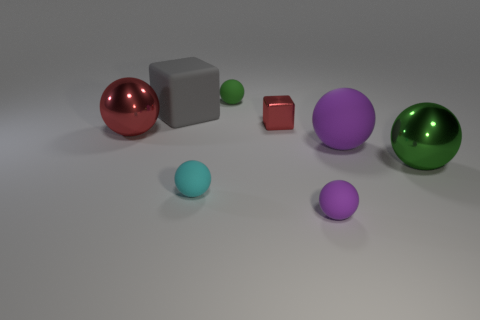What shape is the shiny thing that is left of the tiny green thing to the left of the green sphere that is in front of the small red object?
Keep it short and to the point. Sphere. What is the red block made of?
Offer a very short reply. Metal. There is a cube that is the same material as the large red thing; what color is it?
Ensure brevity in your answer.  Red. There is a metallic object to the left of the big gray thing; are there any red balls left of it?
Give a very brief answer. No. What number of other objects are the same shape as the large purple matte object?
Provide a succinct answer. 5. Is the shape of the large rubber object to the left of the tiny red object the same as the red metallic object to the right of the red sphere?
Give a very brief answer. Yes. There is a metallic ball that is to the right of the large rubber object behind the metallic block; what number of large gray cubes are on the left side of it?
Offer a very short reply. 1. The small metallic thing is what color?
Keep it short and to the point. Red. What number of other things are the same size as the green metallic sphere?
Give a very brief answer. 3. What is the material of the big gray object that is the same shape as the tiny red shiny thing?
Your answer should be compact. Rubber. 